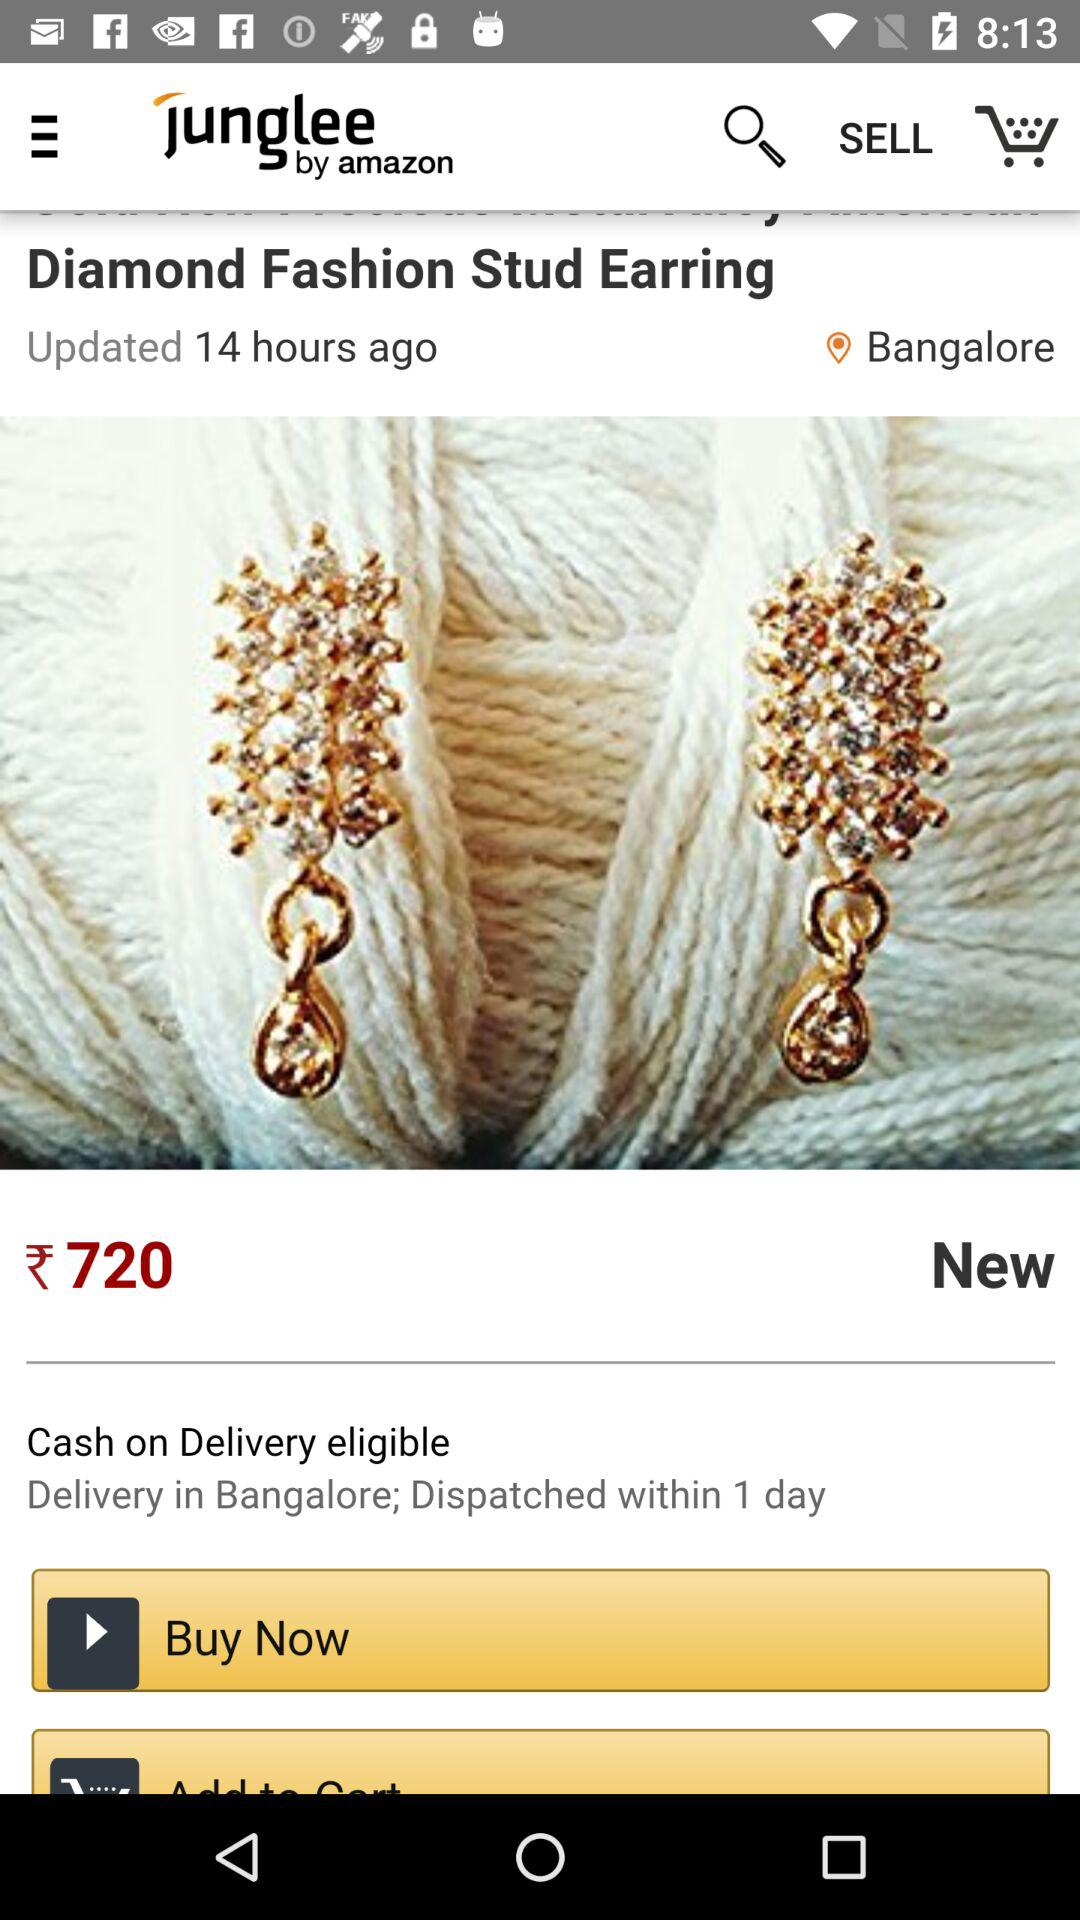What is the price of the product? The price of the product is ₹720. 